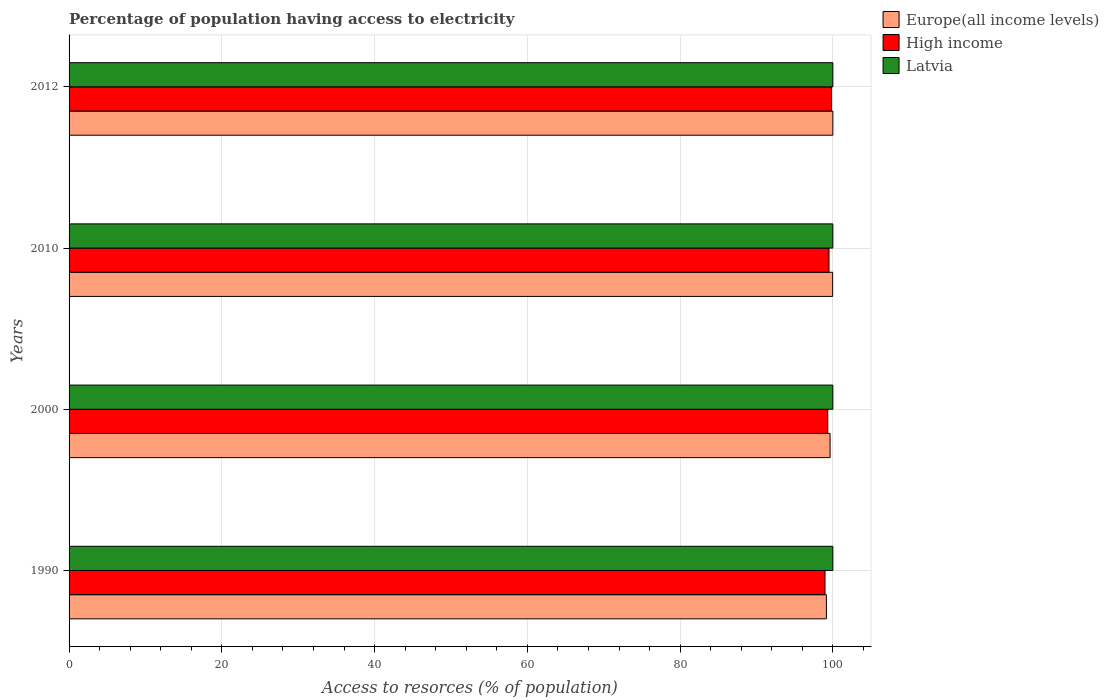How many different coloured bars are there?
Your response must be concise. 3. How many groups of bars are there?
Make the answer very short. 4. Are the number of bars per tick equal to the number of legend labels?
Keep it short and to the point. Yes. How many bars are there on the 2nd tick from the top?
Make the answer very short. 3. What is the label of the 2nd group of bars from the top?
Ensure brevity in your answer.  2010. What is the percentage of population having access to electricity in Europe(all income levels) in 2012?
Your response must be concise. 100. Across all years, what is the maximum percentage of population having access to electricity in Latvia?
Give a very brief answer. 100. Across all years, what is the minimum percentage of population having access to electricity in Latvia?
Your answer should be compact. 100. In which year was the percentage of population having access to electricity in Latvia maximum?
Offer a terse response. 1990. In which year was the percentage of population having access to electricity in High income minimum?
Make the answer very short. 1990. What is the total percentage of population having access to electricity in Latvia in the graph?
Provide a short and direct response. 400. What is the difference between the percentage of population having access to electricity in High income in 2000 and the percentage of population having access to electricity in Latvia in 2012?
Your response must be concise. -0.67. What is the average percentage of population having access to electricity in Europe(all income levels) per year?
Keep it short and to the point. 99.69. What is the ratio of the percentage of population having access to electricity in High income in 2000 to that in 2012?
Your answer should be compact. 1. Is the difference between the percentage of population having access to electricity in Latvia in 1990 and 2010 greater than the difference between the percentage of population having access to electricity in Europe(all income levels) in 1990 and 2010?
Your answer should be very brief. Yes. What is the difference between the highest and the second highest percentage of population having access to electricity in Europe(all income levels)?
Keep it short and to the point. 0.03. What is the difference between the highest and the lowest percentage of population having access to electricity in High income?
Offer a terse response. 0.85. What does the 1st bar from the top in 2010 represents?
Give a very brief answer. Latvia. What does the 1st bar from the bottom in 2000 represents?
Ensure brevity in your answer.  Europe(all income levels). Is it the case that in every year, the sum of the percentage of population having access to electricity in Europe(all income levels) and percentage of population having access to electricity in Latvia is greater than the percentage of population having access to electricity in High income?
Ensure brevity in your answer.  Yes. Are the values on the major ticks of X-axis written in scientific E-notation?
Provide a short and direct response. No. Does the graph contain any zero values?
Provide a succinct answer. No. How are the legend labels stacked?
Keep it short and to the point. Vertical. What is the title of the graph?
Give a very brief answer. Percentage of population having access to electricity. What is the label or title of the X-axis?
Give a very brief answer. Access to resorces (% of population). What is the label or title of the Y-axis?
Provide a succinct answer. Years. What is the Access to resorces (% of population) of Europe(all income levels) in 1990?
Offer a very short reply. 99.15. What is the Access to resorces (% of population) of High income in 1990?
Offer a terse response. 98.97. What is the Access to resorces (% of population) in Europe(all income levels) in 2000?
Your answer should be very brief. 99.63. What is the Access to resorces (% of population) in High income in 2000?
Provide a succinct answer. 99.33. What is the Access to resorces (% of population) in Latvia in 2000?
Make the answer very short. 100. What is the Access to resorces (% of population) of Europe(all income levels) in 2010?
Provide a succinct answer. 99.97. What is the Access to resorces (% of population) in High income in 2010?
Provide a short and direct response. 99.49. What is the Access to resorces (% of population) in Latvia in 2010?
Offer a very short reply. 100. What is the Access to resorces (% of population) in Europe(all income levels) in 2012?
Ensure brevity in your answer.  100. What is the Access to resorces (% of population) in High income in 2012?
Ensure brevity in your answer.  99.82. What is the Access to resorces (% of population) in Latvia in 2012?
Offer a terse response. 100. Across all years, what is the maximum Access to resorces (% of population) in Europe(all income levels)?
Your answer should be compact. 100. Across all years, what is the maximum Access to resorces (% of population) in High income?
Your response must be concise. 99.82. Across all years, what is the maximum Access to resorces (% of population) of Latvia?
Provide a short and direct response. 100. Across all years, what is the minimum Access to resorces (% of population) of Europe(all income levels)?
Offer a very short reply. 99.15. Across all years, what is the minimum Access to resorces (% of population) in High income?
Give a very brief answer. 98.97. What is the total Access to resorces (% of population) of Europe(all income levels) in the graph?
Ensure brevity in your answer.  398.76. What is the total Access to resorces (% of population) in High income in the graph?
Your answer should be compact. 397.62. What is the total Access to resorces (% of population) in Latvia in the graph?
Make the answer very short. 400. What is the difference between the Access to resorces (% of population) of Europe(all income levels) in 1990 and that in 2000?
Offer a terse response. -0.48. What is the difference between the Access to resorces (% of population) in High income in 1990 and that in 2000?
Give a very brief answer. -0.36. What is the difference between the Access to resorces (% of population) in Europe(all income levels) in 1990 and that in 2010?
Keep it short and to the point. -0.82. What is the difference between the Access to resorces (% of population) of High income in 1990 and that in 2010?
Your answer should be compact. -0.52. What is the difference between the Access to resorces (% of population) of Europe(all income levels) in 1990 and that in 2012?
Provide a succinct answer. -0.85. What is the difference between the Access to resorces (% of population) of High income in 1990 and that in 2012?
Your answer should be compact. -0.85. What is the difference between the Access to resorces (% of population) of Latvia in 1990 and that in 2012?
Keep it short and to the point. 0. What is the difference between the Access to resorces (% of population) of Europe(all income levels) in 2000 and that in 2010?
Your answer should be very brief. -0.34. What is the difference between the Access to resorces (% of population) of High income in 2000 and that in 2010?
Provide a succinct answer. -0.16. What is the difference between the Access to resorces (% of population) of Europe(all income levels) in 2000 and that in 2012?
Offer a terse response. -0.37. What is the difference between the Access to resorces (% of population) in High income in 2000 and that in 2012?
Give a very brief answer. -0.49. What is the difference between the Access to resorces (% of population) of Europe(all income levels) in 2010 and that in 2012?
Ensure brevity in your answer.  -0.03. What is the difference between the Access to resorces (% of population) of High income in 2010 and that in 2012?
Offer a very short reply. -0.33. What is the difference between the Access to resorces (% of population) in Latvia in 2010 and that in 2012?
Provide a short and direct response. 0. What is the difference between the Access to resorces (% of population) of Europe(all income levels) in 1990 and the Access to resorces (% of population) of High income in 2000?
Your answer should be compact. -0.18. What is the difference between the Access to resorces (% of population) in Europe(all income levels) in 1990 and the Access to resorces (% of population) in Latvia in 2000?
Keep it short and to the point. -0.85. What is the difference between the Access to resorces (% of population) in High income in 1990 and the Access to resorces (% of population) in Latvia in 2000?
Provide a short and direct response. -1.03. What is the difference between the Access to resorces (% of population) of Europe(all income levels) in 1990 and the Access to resorces (% of population) of High income in 2010?
Give a very brief answer. -0.34. What is the difference between the Access to resorces (% of population) in Europe(all income levels) in 1990 and the Access to resorces (% of population) in Latvia in 2010?
Give a very brief answer. -0.85. What is the difference between the Access to resorces (% of population) in High income in 1990 and the Access to resorces (% of population) in Latvia in 2010?
Ensure brevity in your answer.  -1.03. What is the difference between the Access to resorces (% of population) of Europe(all income levels) in 1990 and the Access to resorces (% of population) of High income in 2012?
Give a very brief answer. -0.67. What is the difference between the Access to resorces (% of population) of Europe(all income levels) in 1990 and the Access to resorces (% of population) of Latvia in 2012?
Your answer should be compact. -0.85. What is the difference between the Access to resorces (% of population) in High income in 1990 and the Access to resorces (% of population) in Latvia in 2012?
Offer a terse response. -1.03. What is the difference between the Access to resorces (% of population) of Europe(all income levels) in 2000 and the Access to resorces (% of population) of High income in 2010?
Your answer should be compact. 0.14. What is the difference between the Access to resorces (% of population) in Europe(all income levels) in 2000 and the Access to resorces (% of population) in Latvia in 2010?
Offer a very short reply. -0.37. What is the difference between the Access to resorces (% of population) in High income in 2000 and the Access to resorces (% of population) in Latvia in 2010?
Offer a terse response. -0.67. What is the difference between the Access to resorces (% of population) of Europe(all income levels) in 2000 and the Access to resorces (% of population) of High income in 2012?
Your answer should be compact. -0.19. What is the difference between the Access to resorces (% of population) in Europe(all income levels) in 2000 and the Access to resorces (% of population) in Latvia in 2012?
Ensure brevity in your answer.  -0.37. What is the difference between the Access to resorces (% of population) in High income in 2000 and the Access to resorces (% of population) in Latvia in 2012?
Ensure brevity in your answer.  -0.67. What is the difference between the Access to resorces (% of population) in Europe(all income levels) in 2010 and the Access to resorces (% of population) in High income in 2012?
Offer a terse response. 0.15. What is the difference between the Access to resorces (% of population) of Europe(all income levels) in 2010 and the Access to resorces (% of population) of Latvia in 2012?
Offer a terse response. -0.03. What is the difference between the Access to resorces (% of population) in High income in 2010 and the Access to resorces (% of population) in Latvia in 2012?
Offer a terse response. -0.51. What is the average Access to resorces (% of population) of Europe(all income levels) per year?
Provide a short and direct response. 99.69. What is the average Access to resorces (% of population) in High income per year?
Keep it short and to the point. 99.4. In the year 1990, what is the difference between the Access to resorces (% of population) in Europe(all income levels) and Access to resorces (% of population) in High income?
Your response must be concise. 0.18. In the year 1990, what is the difference between the Access to resorces (% of population) in Europe(all income levels) and Access to resorces (% of population) in Latvia?
Offer a terse response. -0.85. In the year 1990, what is the difference between the Access to resorces (% of population) in High income and Access to resorces (% of population) in Latvia?
Make the answer very short. -1.03. In the year 2000, what is the difference between the Access to resorces (% of population) of Europe(all income levels) and Access to resorces (% of population) of High income?
Your answer should be very brief. 0.3. In the year 2000, what is the difference between the Access to resorces (% of population) in Europe(all income levels) and Access to resorces (% of population) in Latvia?
Provide a short and direct response. -0.37. In the year 2000, what is the difference between the Access to resorces (% of population) of High income and Access to resorces (% of population) of Latvia?
Provide a succinct answer. -0.67. In the year 2010, what is the difference between the Access to resorces (% of population) in Europe(all income levels) and Access to resorces (% of population) in High income?
Give a very brief answer. 0.48. In the year 2010, what is the difference between the Access to resorces (% of population) in Europe(all income levels) and Access to resorces (% of population) in Latvia?
Your answer should be compact. -0.03. In the year 2010, what is the difference between the Access to resorces (% of population) of High income and Access to resorces (% of population) of Latvia?
Ensure brevity in your answer.  -0.51. In the year 2012, what is the difference between the Access to resorces (% of population) of Europe(all income levels) and Access to resorces (% of population) of High income?
Make the answer very short. 0.18. In the year 2012, what is the difference between the Access to resorces (% of population) in High income and Access to resorces (% of population) in Latvia?
Offer a very short reply. -0.18. What is the ratio of the Access to resorces (% of population) in Latvia in 1990 to that in 2000?
Give a very brief answer. 1. What is the ratio of the Access to resorces (% of population) of Europe(all income levels) in 1990 to that in 2010?
Make the answer very short. 0.99. What is the ratio of the Access to resorces (% of population) in Latvia in 1990 to that in 2010?
Provide a short and direct response. 1. What is the ratio of the Access to resorces (% of population) in Europe(all income levels) in 1990 to that in 2012?
Ensure brevity in your answer.  0.99. What is the ratio of the Access to resorces (% of population) of Latvia in 1990 to that in 2012?
Your answer should be very brief. 1. What is the ratio of the Access to resorces (% of population) in Europe(all income levels) in 2000 to that in 2010?
Your response must be concise. 1. What is the ratio of the Access to resorces (% of population) of High income in 2000 to that in 2010?
Provide a short and direct response. 1. What is the ratio of the Access to resorces (% of population) of Latvia in 2000 to that in 2010?
Offer a terse response. 1. What is the ratio of the Access to resorces (% of population) in High income in 2010 to that in 2012?
Your answer should be compact. 1. What is the difference between the highest and the second highest Access to resorces (% of population) of Europe(all income levels)?
Keep it short and to the point. 0.03. What is the difference between the highest and the second highest Access to resorces (% of population) in High income?
Keep it short and to the point. 0.33. What is the difference between the highest and the lowest Access to resorces (% of population) in Europe(all income levels)?
Provide a short and direct response. 0.85. What is the difference between the highest and the lowest Access to resorces (% of population) of High income?
Your response must be concise. 0.85. What is the difference between the highest and the lowest Access to resorces (% of population) in Latvia?
Ensure brevity in your answer.  0. 